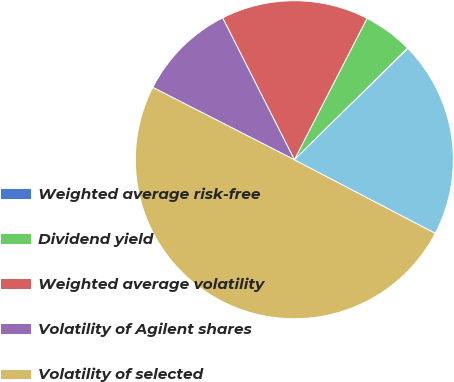Convert chart. <chart><loc_0><loc_0><loc_500><loc_500><pie_chart><fcel>Weighted average risk-free<fcel>Dividend yield<fcel>Weighted average volatility<fcel>Volatility of Agilent shares<fcel>Volatility of selected<fcel>Price-wise correlation with<nl><fcel>0.06%<fcel>5.05%<fcel>15.01%<fcel>10.03%<fcel>49.87%<fcel>19.99%<nl></chart> 